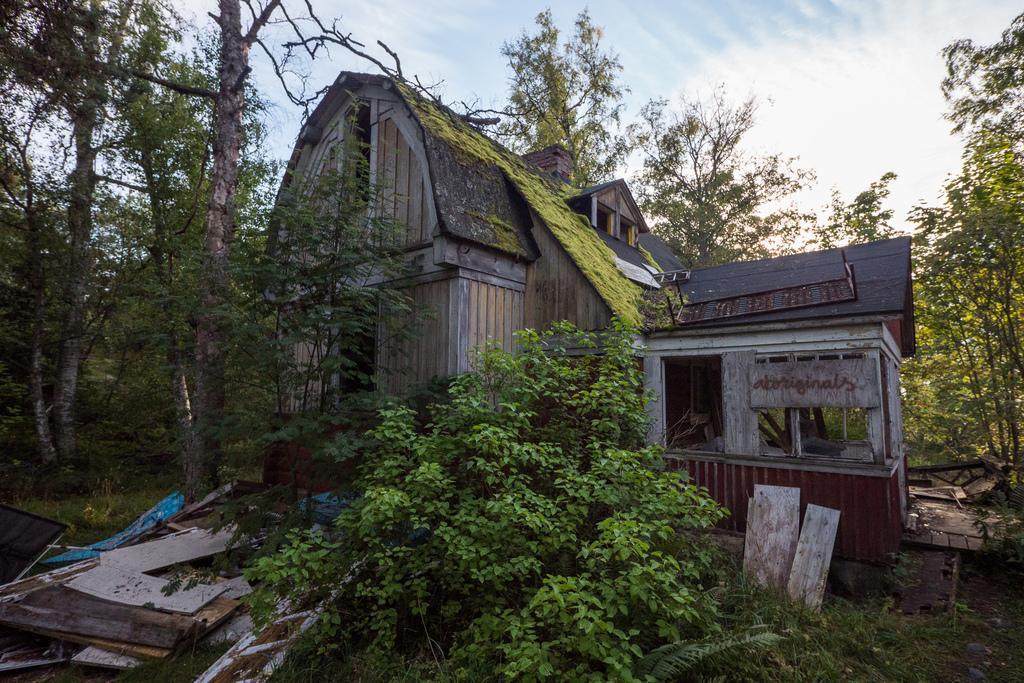In one or two sentences, can you explain what this image depicts? In this picture there is a building and there are trees and there is text on the board. At the bottom there are wooden objects on the grass. At the top there is sky and there are clouds. 